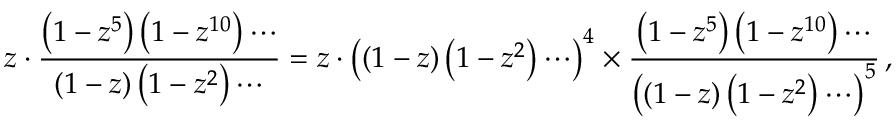Convert formula to latex. <formula><loc_0><loc_0><loc_500><loc_500>z \cdot { \frac { \left ( 1 - z ^ { 5 } \right ) \left ( 1 - z ^ { 1 0 } \right ) \cdots } { \left ( 1 - z \right ) \left ( 1 - z ^ { 2 } \right ) \cdots } } = z \cdot \left ( ( 1 - z ) \left ( 1 - z ^ { 2 } \right ) \cdots \right ) ^ { 4 } \times { \frac { \left ( 1 - z ^ { 5 } \right ) \left ( 1 - z ^ { 1 0 } \right ) \cdots } { \left ( \left ( 1 - z \right ) \left ( 1 - z ^ { 2 } \right ) \cdots \right ) ^ { 5 } } } \, ,</formula> 